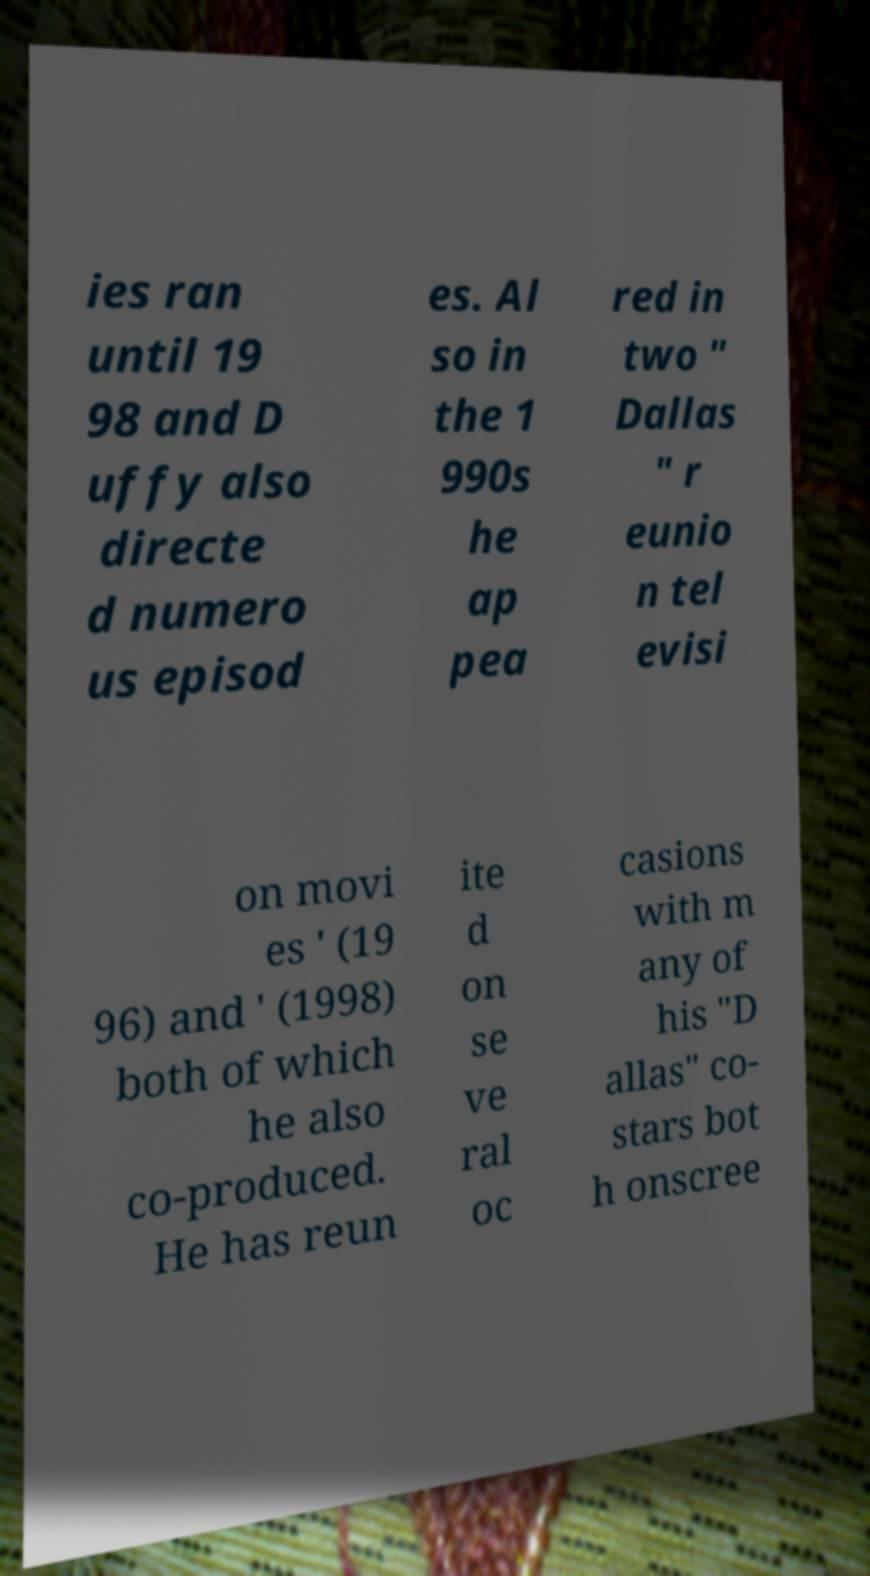What messages or text are displayed in this image? I need them in a readable, typed format. ies ran until 19 98 and D uffy also directe d numero us episod es. Al so in the 1 990s he ap pea red in two " Dallas " r eunio n tel evisi on movi es ' (19 96) and ' (1998) both of which he also co-produced. He has reun ite d on se ve ral oc casions with m any of his "D allas" co- stars bot h onscree 